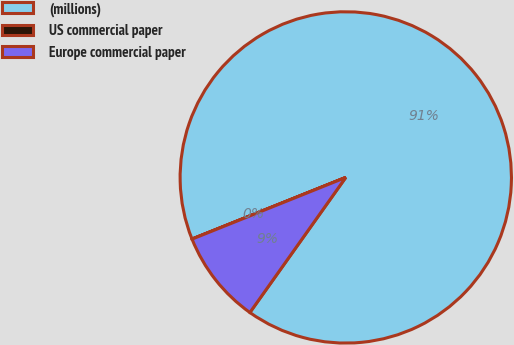Convert chart. <chart><loc_0><loc_0><loc_500><loc_500><pie_chart><fcel>(millions)<fcel>US commercial paper<fcel>Europe commercial paper<nl><fcel>90.89%<fcel>0.01%<fcel>9.1%<nl></chart> 